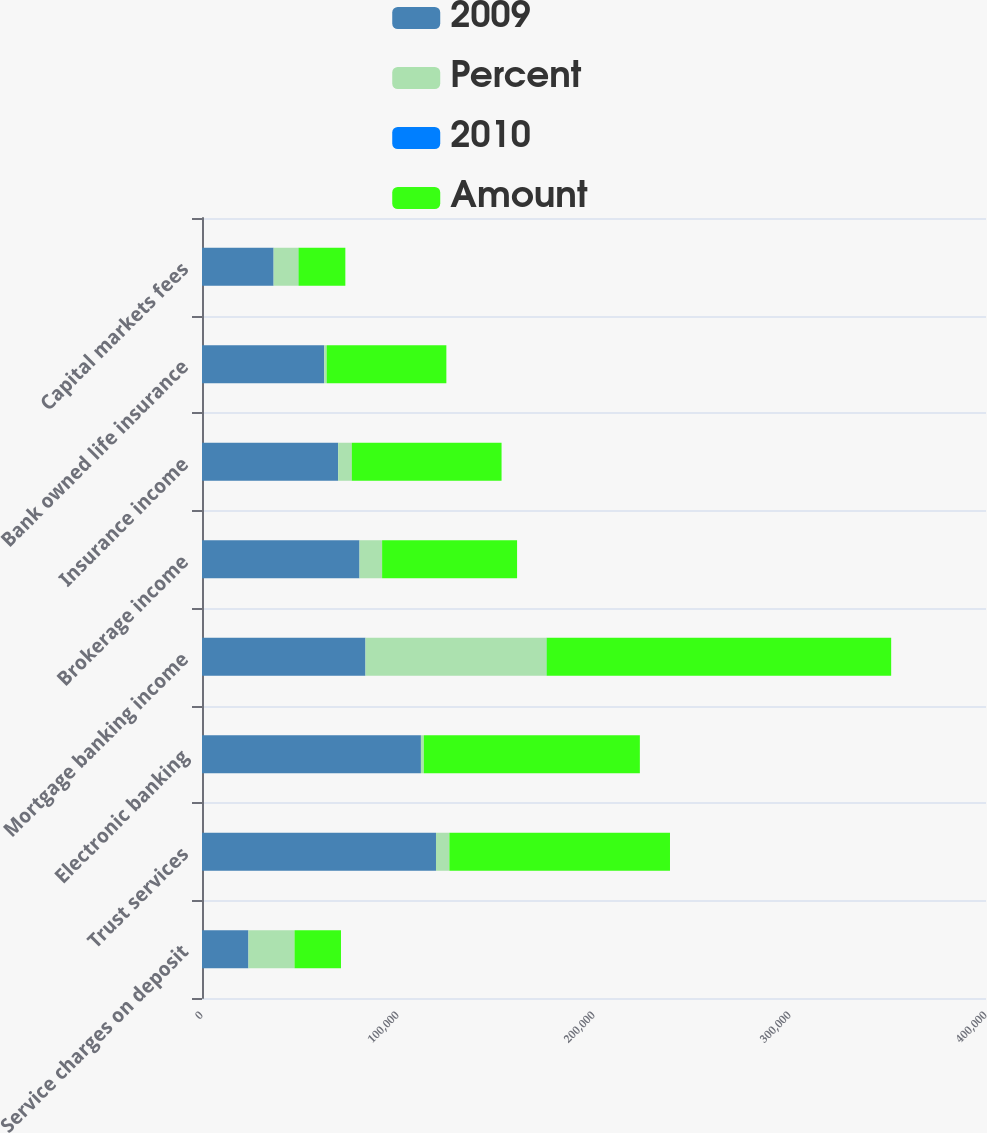<chart> <loc_0><loc_0><loc_500><loc_500><stacked_bar_chart><ecel><fcel>Service charges on deposit<fcel>Trust services<fcel>Electronic banking<fcel>Mortgage banking income<fcel>Brokerage income<fcel>Insurance income<fcel>Bank owned life insurance<fcel>Capital markets fees<nl><fcel>2009<fcel>23697<fcel>119382<fcel>111697<fcel>83408<fcel>80367<fcel>69470<fcel>62336<fcel>36540<nl><fcel>Percent<fcel>23508<fcel>6827<fcel>1463<fcel>92374<fcel>11512<fcel>6943<fcel>1270<fcel>12654<nl><fcel>2010<fcel>9<fcel>6<fcel>1<fcel>53<fcel>17<fcel>9<fcel>2<fcel>53<nl><fcel>Amount<fcel>23697<fcel>112555<fcel>110234<fcel>175782<fcel>68855<fcel>76413<fcel>61066<fcel>23886<nl></chart> 